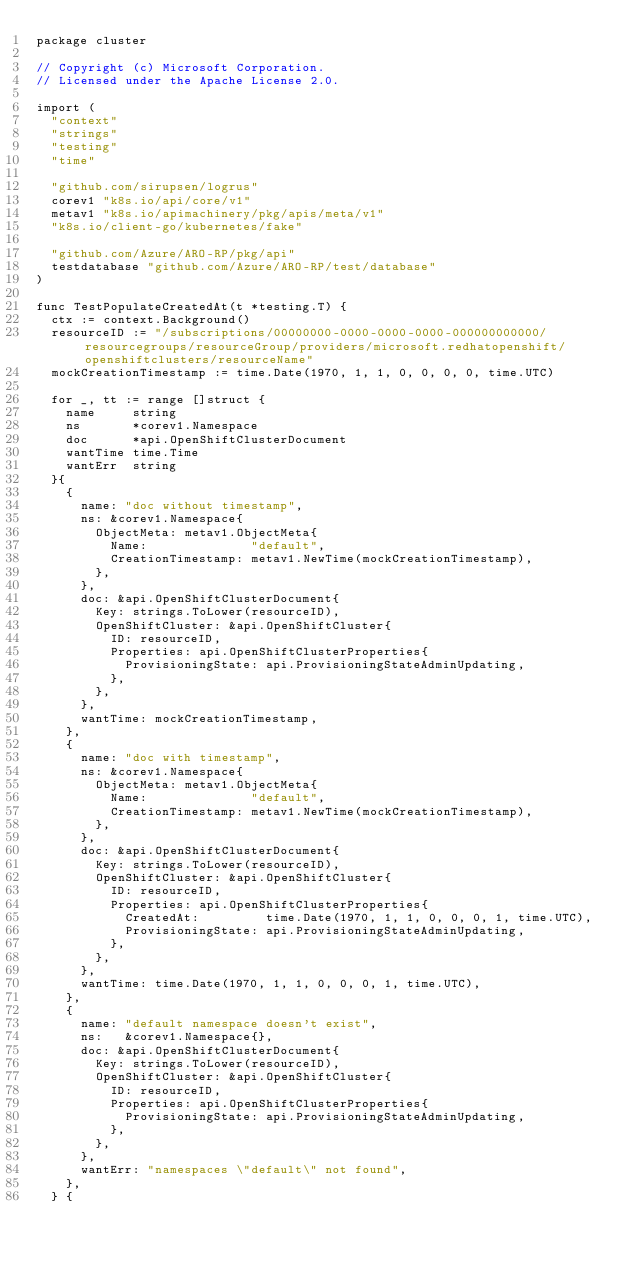<code> <loc_0><loc_0><loc_500><loc_500><_Go_>package cluster

// Copyright (c) Microsoft Corporation.
// Licensed under the Apache License 2.0.

import (
	"context"
	"strings"
	"testing"
	"time"

	"github.com/sirupsen/logrus"
	corev1 "k8s.io/api/core/v1"
	metav1 "k8s.io/apimachinery/pkg/apis/meta/v1"
	"k8s.io/client-go/kubernetes/fake"

	"github.com/Azure/ARO-RP/pkg/api"
	testdatabase "github.com/Azure/ARO-RP/test/database"
)

func TestPopulateCreatedAt(t *testing.T) {
	ctx := context.Background()
	resourceID := "/subscriptions/00000000-0000-0000-0000-000000000000/resourcegroups/resourceGroup/providers/microsoft.redhatopenshift/openshiftclusters/resourceName"
	mockCreationTimestamp := time.Date(1970, 1, 1, 0, 0, 0, 0, time.UTC)

	for _, tt := range []struct {
		name     string
		ns       *corev1.Namespace
		doc      *api.OpenShiftClusterDocument
		wantTime time.Time
		wantErr  string
	}{
		{
			name: "doc without timestamp",
			ns: &corev1.Namespace{
				ObjectMeta: metav1.ObjectMeta{
					Name:              "default",
					CreationTimestamp: metav1.NewTime(mockCreationTimestamp),
				},
			},
			doc: &api.OpenShiftClusterDocument{
				Key: strings.ToLower(resourceID),
				OpenShiftCluster: &api.OpenShiftCluster{
					ID: resourceID,
					Properties: api.OpenShiftClusterProperties{
						ProvisioningState: api.ProvisioningStateAdminUpdating,
					},
				},
			},
			wantTime: mockCreationTimestamp,
		},
		{
			name: "doc with timestamp",
			ns: &corev1.Namespace{
				ObjectMeta: metav1.ObjectMeta{
					Name:              "default",
					CreationTimestamp: metav1.NewTime(mockCreationTimestamp),
				},
			},
			doc: &api.OpenShiftClusterDocument{
				Key: strings.ToLower(resourceID),
				OpenShiftCluster: &api.OpenShiftCluster{
					ID: resourceID,
					Properties: api.OpenShiftClusterProperties{
						CreatedAt:         time.Date(1970, 1, 1, 0, 0, 0, 1, time.UTC),
						ProvisioningState: api.ProvisioningStateAdminUpdating,
					},
				},
			},
			wantTime: time.Date(1970, 1, 1, 0, 0, 0, 1, time.UTC),
		},
		{
			name: "default namespace doesn't exist",
			ns:   &corev1.Namespace{},
			doc: &api.OpenShiftClusterDocument{
				Key: strings.ToLower(resourceID),
				OpenShiftCluster: &api.OpenShiftCluster{
					ID: resourceID,
					Properties: api.OpenShiftClusterProperties{
						ProvisioningState: api.ProvisioningStateAdminUpdating,
					},
				},
			},
			wantErr: "namespaces \"default\" not found",
		},
	} {</code> 